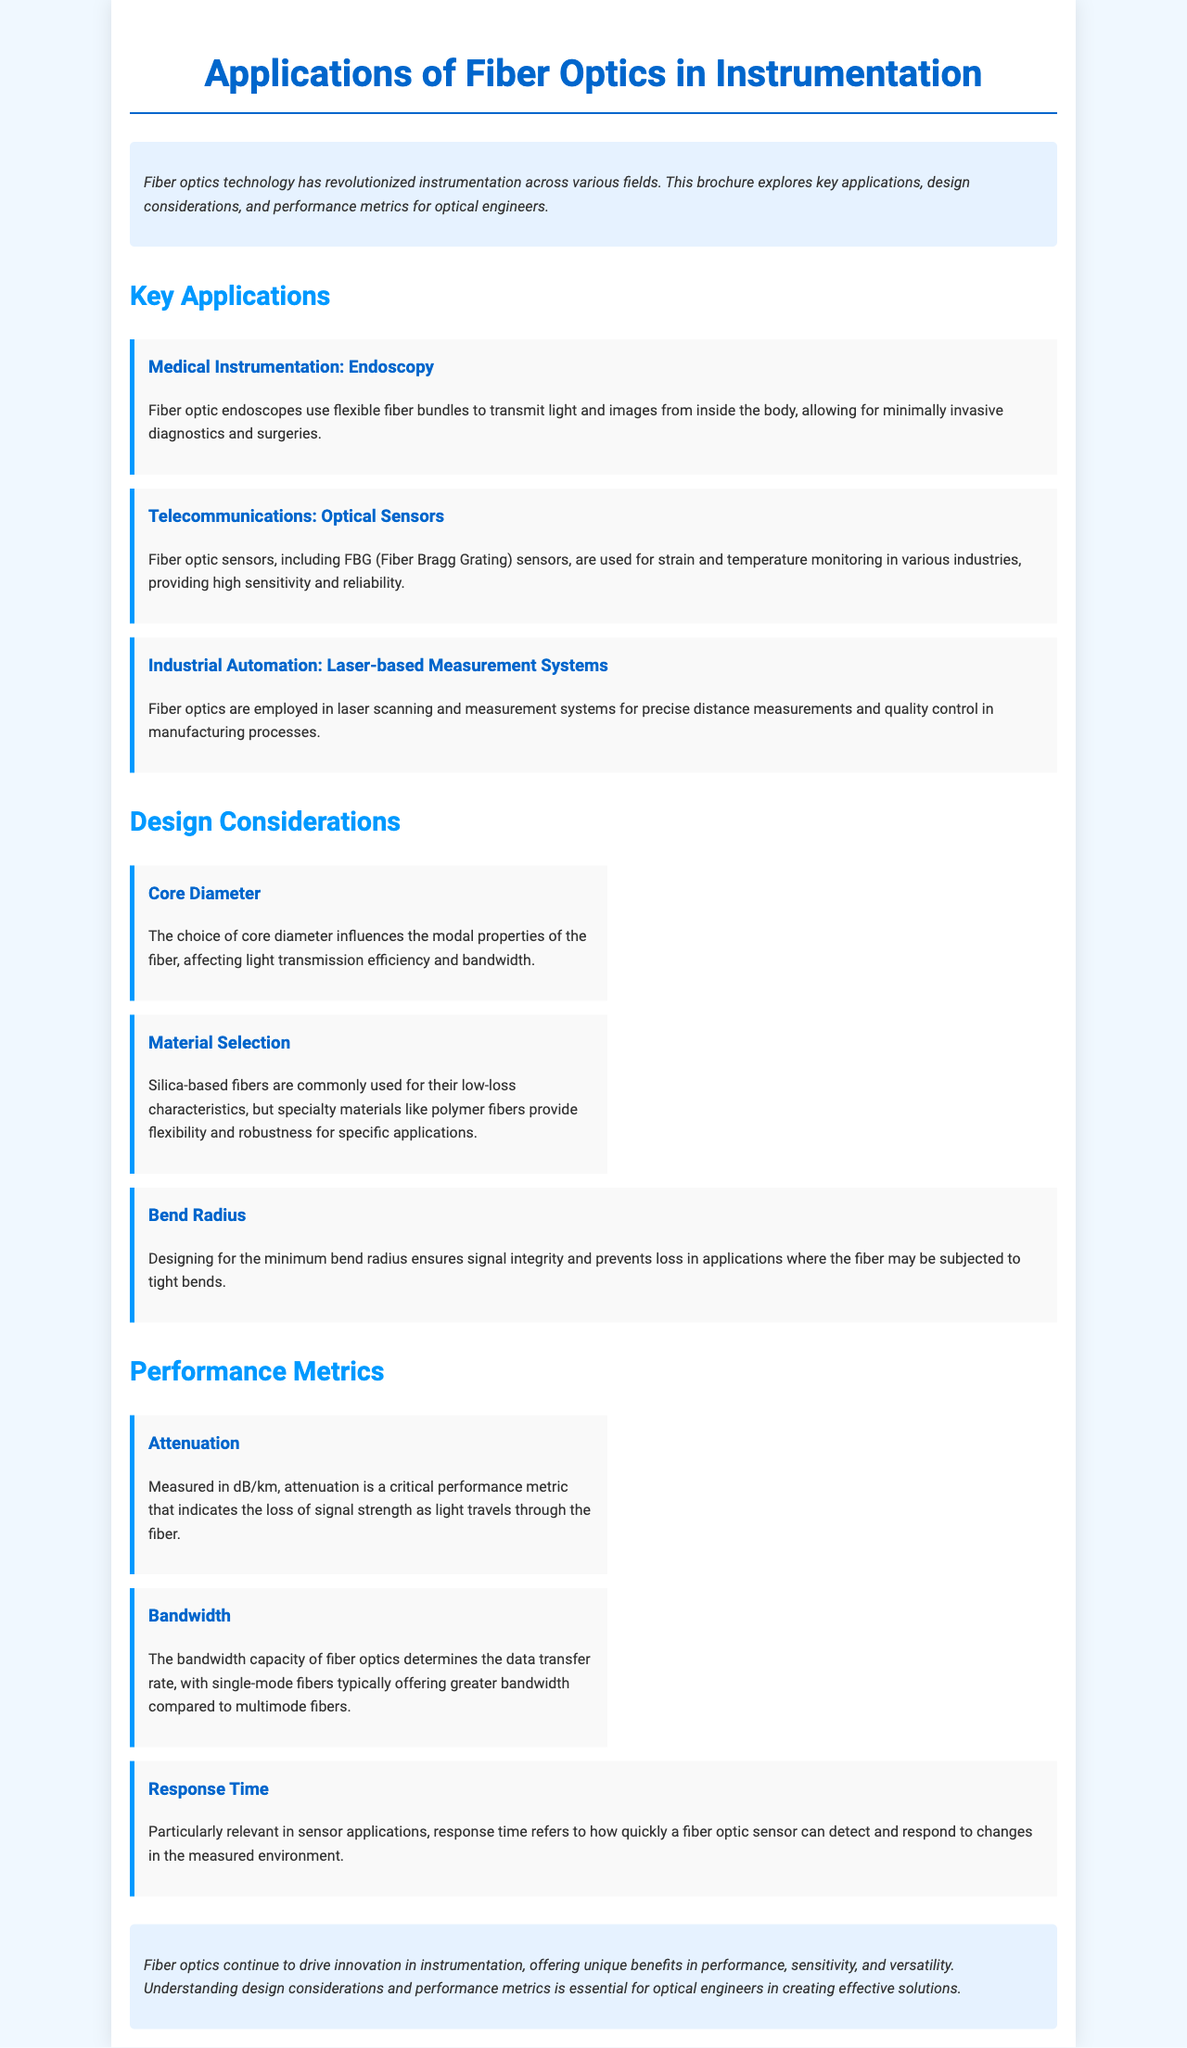What is the title of the brochure? The title is clearly stated at the top of the document, which describes the main focus of the content.
Answer: Applications of Fiber Optics in Instrumentation What is one application of fiber optics in medical instrumentation? The document mentions a specific application under medical instrumentation, highlighting its purpose and function.
Answer: Endoscopy What material is commonly used in fiber optics for low-loss characteristics? The document discusses material selection and specifies the material known for its low-loss traits.
Answer: Silica What performance metric is measured in dB/km? The document describes a specific performance metric that quantifies signal loss in optical fibers.
Answer: Attenuation What does the bandwidth capacity determine in fiber optics? The document explains the significance of bandwidth capacity in terms of data transfer capabilities.
Answer: Data transfer rate Why is the choice of core diameter important? This question requires understanding the impact of core diameter on light transmission, as mentioned in the design considerations section.
Answer: Modal properties What is a critical consideration when designing for fiber optics? The document notes the importance of a specific design aspect that affects signal integrity in practical applications.
Answer: Bend radius In what section would you find information about fiber optic sensors? The document is organized into sections, and this question asks for the specific section related to applications of fiber optics.
Answer: Key Applications What is the response time relevant to? The document links response time to a specific type of application in fiber optics, emphasizing its importance.
Answer: Sensor applications 